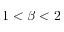Convert formula to latex. <formula><loc_0><loc_0><loc_500><loc_500>1 < \beta < 2</formula> 